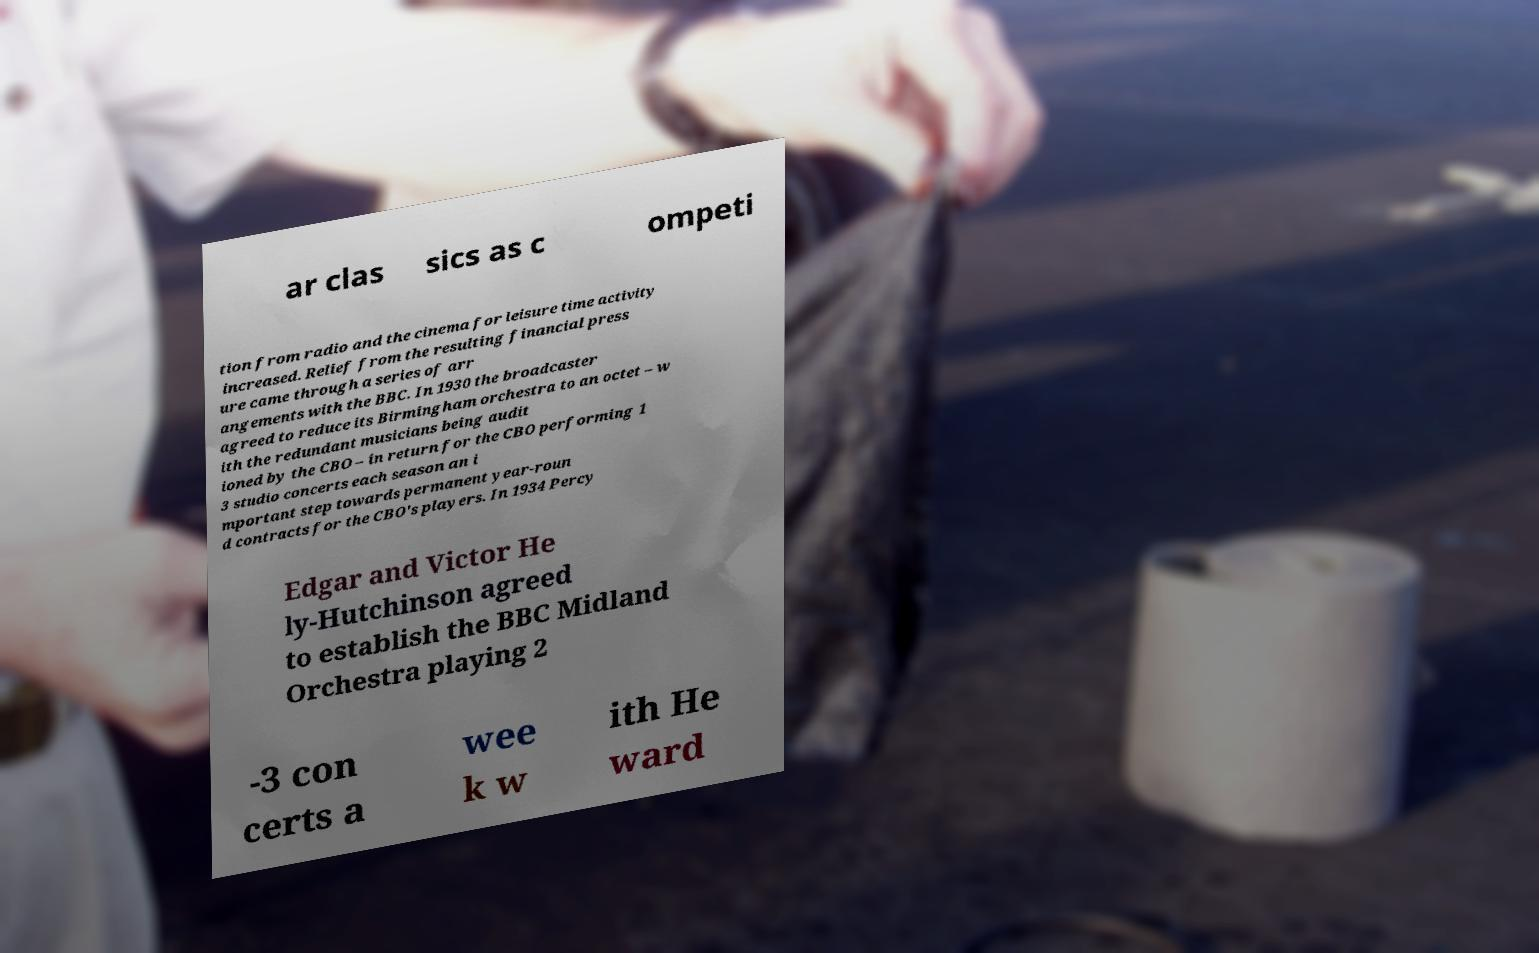There's text embedded in this image that I need extracted. Can you transcribe it verbatim? ar clas sics as c ompeti tion from radio and the cinema for leisure time activity increased. Relief from the resulting financial press ure came through a series of arr angements with the BBC. In 1930 the broadcaster agreed to reduce its Birmingham orchestra to an octet – w ith the redundant musicians being audit ioned by the CBO – in return for the CBO performing 1 3 studio concerts each season an i mportant step towards permanent year-roun d contracts for the CBO's players. In 1934 Percy Edgar and Victor He ly-Hutchinson agreed to establish the BBC Midland Orchestra playing 2 -3 con certs a wee k w ith He ward 